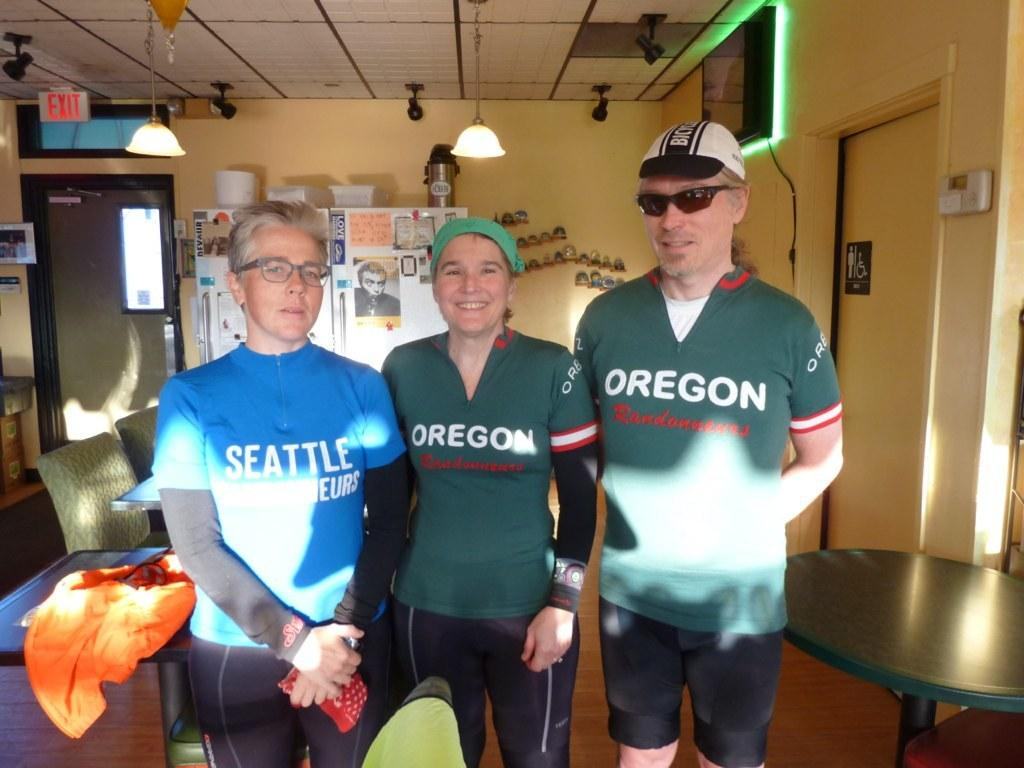<image>
Give a short and clear explanation of the subsequent image. Bike riders with Seattle and Oregon shirts stand in a yellow room. 